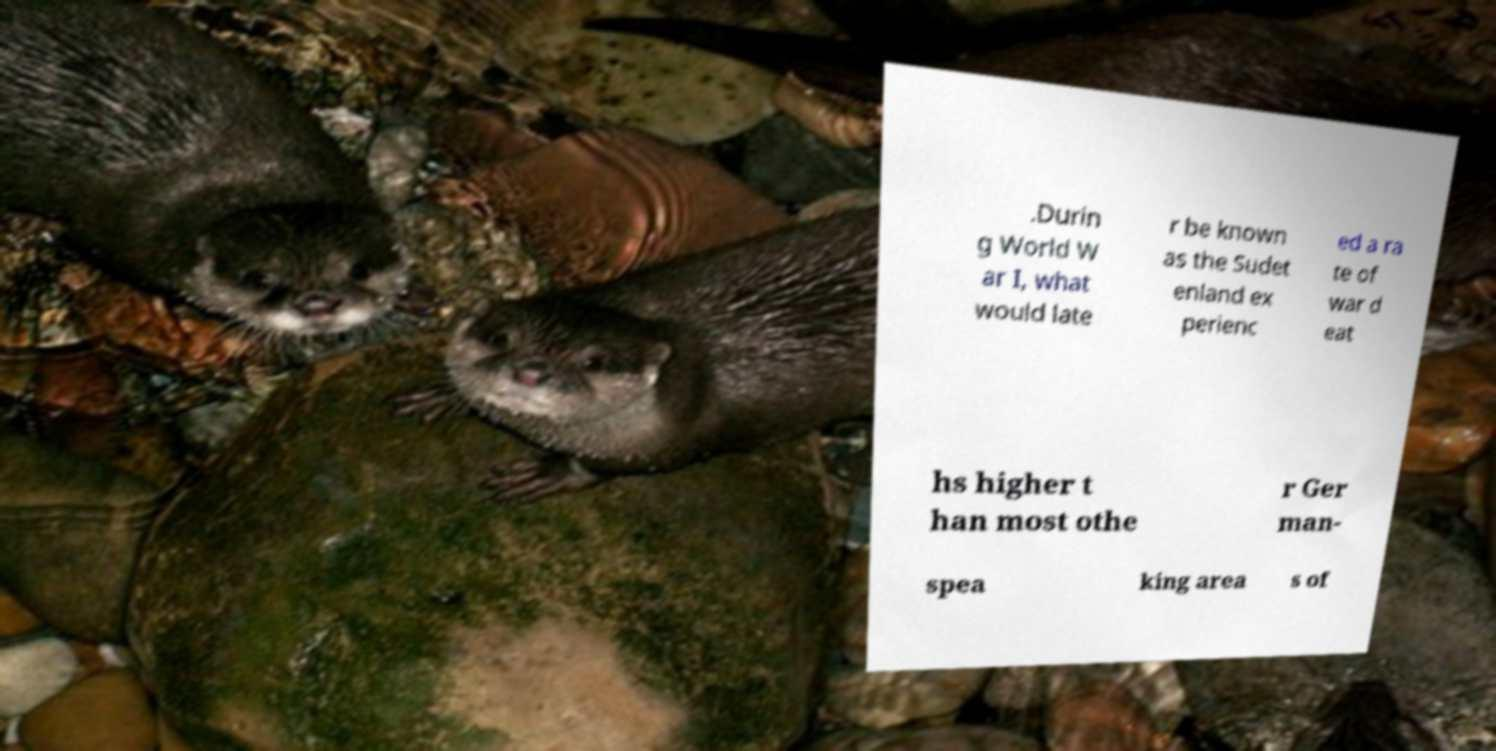Can you read and provide the text displayed in the image?This photo seems to have some interesting text. Can you extract and type it out for me? .Durin g World W ar I, what would late r be known as the Sudet enland ex perienc ed a ra te of war d eat hs higher t han most othe r Ger man- spea king area s of 